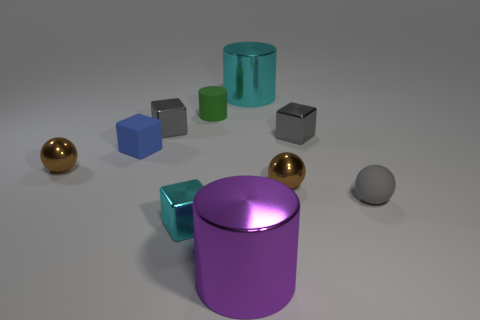Subtract all green balls. How many gray blocks are left? 2 Subtract all shiny cubes. How many cubes are left? 1 Subtract all cyan blocks. How many blocks are left? 3 Subtract all cubes. How many objects are left? 6 Subtract 1 cubes. How many cubes are left? 3 Subtract all tiny blue matte blocks. Subtract all red cubes. How many objects are left? 9 Add 6 tiny brown balls. How many tiny brown balls are left? 8 Add 9 small rubber cubes. How many small rubber cubes exist? 10 Subtract 0 yellow spheres. How many objects are left? 10 Subtract all green blocks. Subtract all yellow cylinders. How many blocks are left? 4 